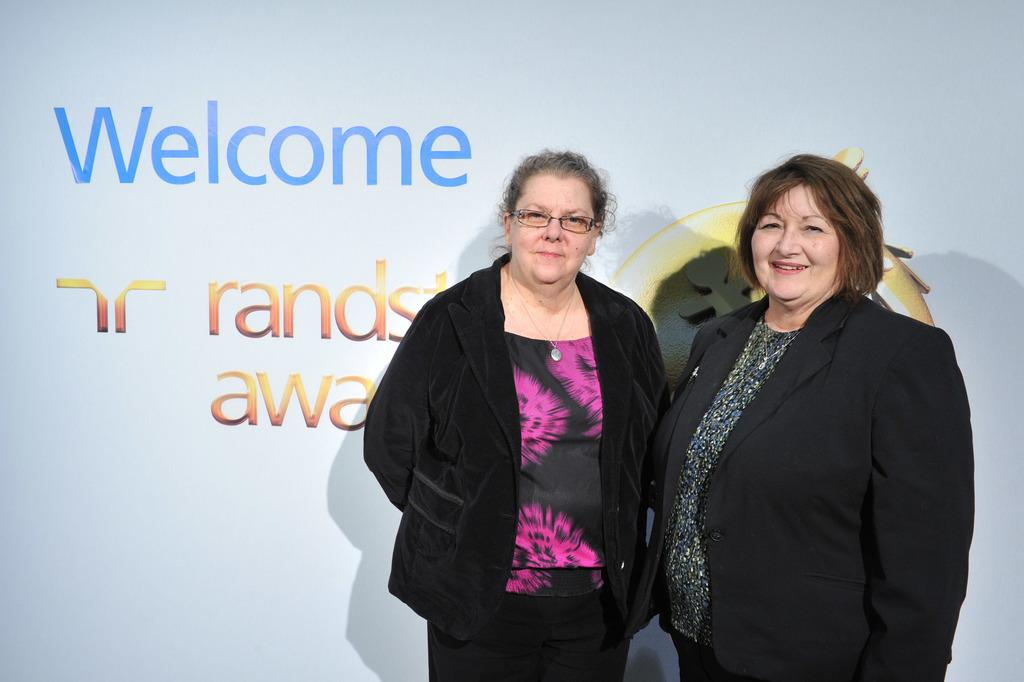How many women are present in the image? There are two women in the image. What are the women wearing? Both women are wearing black color jackets. Can you describe any additional features of one of the women? One of the women is wearing spectacles. What can be seen in the background of the image? There is a banner with text in the background of the image. What type of haircut does the woman with spectacles have in the image? There is no information about the woman's haircut in the image. How many trucks are visible in the background of the image? There are no trucks present in the image; it only features a banner with text in the background. 